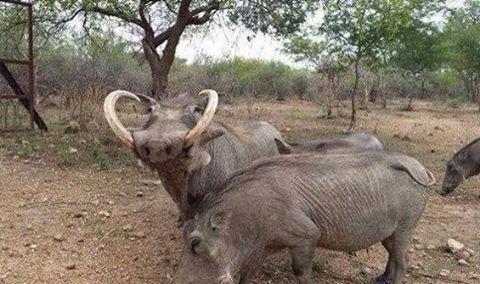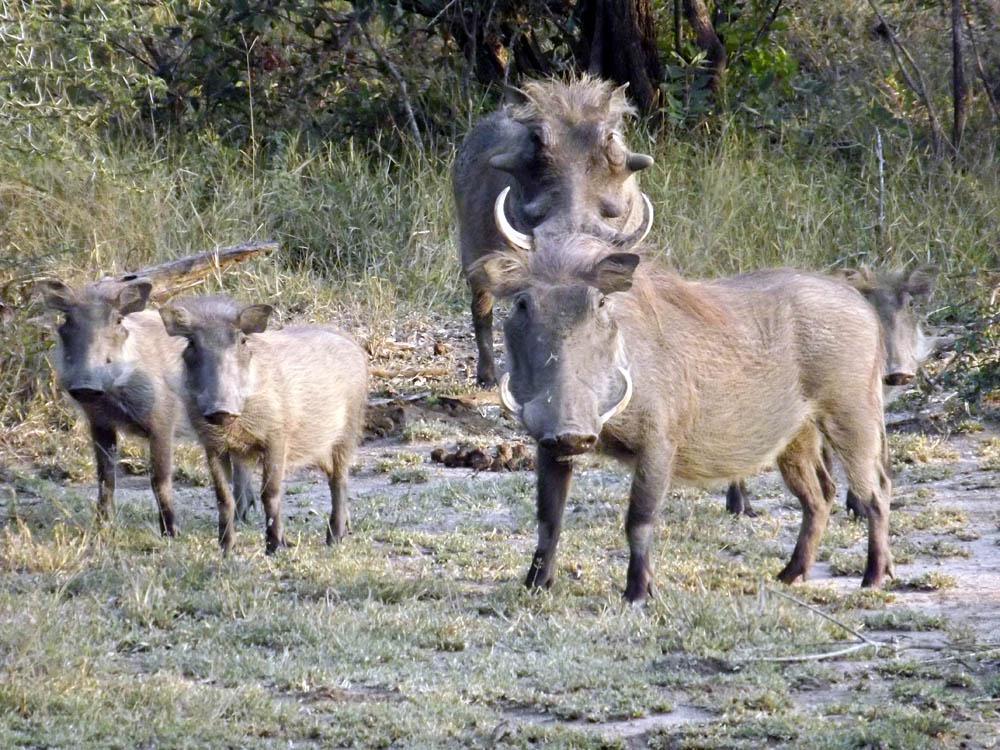The first image is the image on the left, the second image is the image on the right. Examine the images to the left and right. Is the description "One of the images contains exactly four warthogs." accurate? Answer yes or no. Yes. 